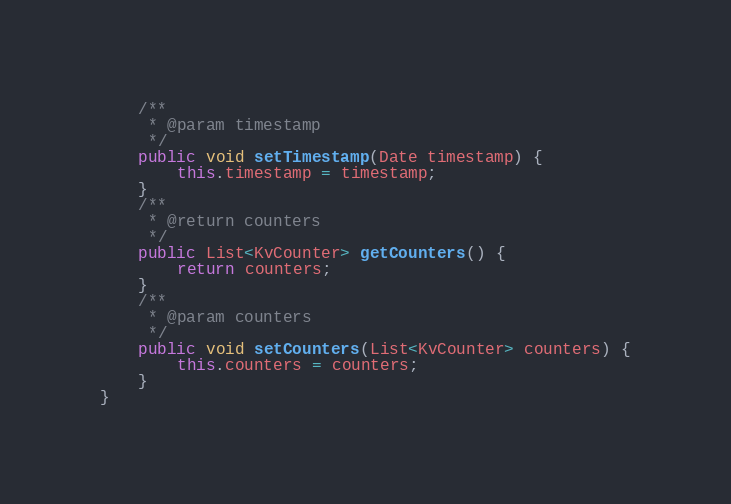<code> <loc_0><loc_0><loc_500><loc_500><_Java_>    /**
     * @param timestamp
     */
    public void setTimestamp(Date timestamp) {
        this.timestamp = timestamp;
    }
    /**
     * @return counters
     */
    public List<KvCounter> getCounters() {
        return counters;
    }
    /**
     * @param counters
     */
    public void setCounters(List<KvCounter> counters) {
        this.counters = counters;
    }
}

</code> 